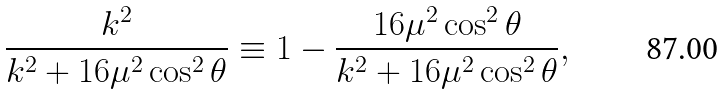<formula> <loc_0><loc_0><loc_500><loc_500>\frac { k ^ { 2 } } { k ^ { 2 } + 1 6 \mu ^ { 2 } \cos ^ { 2 } { \theta } } \equiv 1 - \frac { 1 6 \mu ^ { 2 } \cos ^ { 2 } { \theta } } { k ^ { 2 } + 1 6 \mu ^ { 2 } \cos ^ { 2 } { \theta } } ,</formula> 